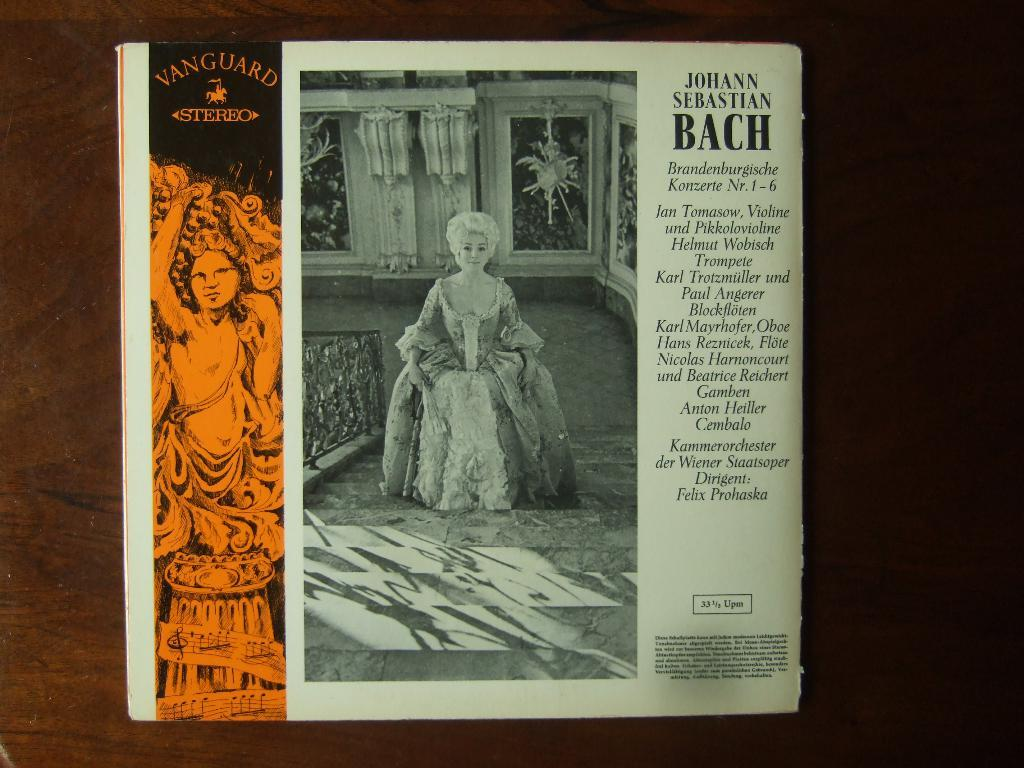<image>
Offer a succinct explanation of the picture presented. A black and white photo with the caption Johann Sebastian Bach. 